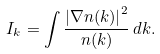Convert formula to latex. <formula><loc_0><loc_0><loc_500><loc_500>I _ { k } = \int \frac { \left | \nabla n ( k ) \right | ^ { 2 } } { n ( k ) } \, d k .</formula> 